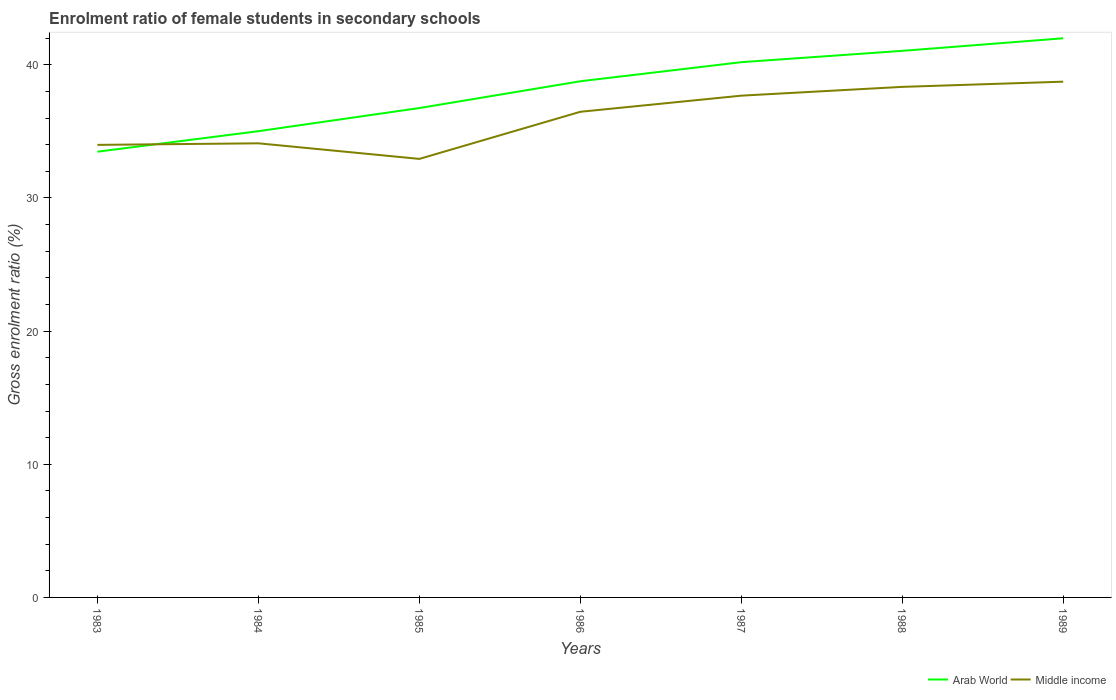Does the line corresponding to Arab World intersect with the line corresponding to Middle income?
Your answer should be compact. Yes. Across all years, what is the maximum enrolment ratio of female students in secondary schools in Middle income?
Provide a short and direct response. 32.93. What is the total enrolment ratio of female students in secondary schools in Arab World in the graph?
Your response must be concise. -1.79. What is the difference between the highest and the second highest enrolment ratio of female students in secondary schools in Arab World?
Provide a short and direct response. 8.52. Is the enrolment ratio of female students in secondary schools in Middle income strictly greater than the enrolment ratio of female students in secondary schools in Arab World over the years?
Your answer should be very brief. No. How many lines are there?
Ensure brevity in your answer.  2. What is the difference between two consecutive major ticks on the Y-axis?
Provide a short and direct response. 10. Does the graph contain any zero values?
Your response must be concise. No. How are the legend labels stacked?
Make the answer very short. Horizontal. What is the title of the graph?
Offer a very short reply. Enrolment ratio of female students in secondary schools. What is the Gross enrolment ratio (%) in Arab World in 1983?
Keep it short and to the point. 33.47. What is the Gross enrolment ratio (%) of Middle income in 1983?
Your answer should be very brief. 33.99. What is the Gross enrolment ratio (%) in Arab World in 1984?
Give a very brief answer. 35.01. What is the Gross enrolment ratio (%) of Middle income in 1984?
Your response must be concise. 34.1. What is the Gross enrolment ratio (%) of Arab World in 1985?
Make the answer very short. 36.75. What is the Gross enrolment ratio (%) in Middle income in 1985?
Your answer should be compact. 32.93. What is the Gross enrolment ratio (%) in Arab World in 1986?
Provide a short and direct response. 38.76. What is the Gross enrolment ratio (%) in Middle income in 1986?
Make the answer very short. 36.47. What is the Gross enrolment ratio (%) of Arab World in 1987?
Give a very brief answer. 40.2. What is the Gross enrolment ratio (%) in Middle income in 1987?
Provide a succinct answer. 37.68. What is the Gross enrolment ratio (%) in Arab World in 1988?
Offer a very short reply. 41.05. What is the Gross enrolment ratio (%) in Middle income in 1988?
Ensure brevity in your answer.  38.34. What is the Gross enrolment ratio (%) in Arab World in 1989?
Your answer should be compact. 41.99. What is the Gross enrolment ratio (%) of Middle income in 1989?
Give a very brief answer. 38.73. Across all years, what is the maximum Gross enrolment ratio (%) in Arab World?
Provide a succinct answer. 41.99. Across all years, what is the maximum Gross enrolment ratio (%) in Middle income?
Offer a terse response. 38.73. Across all years, what is the minimum Gross enrolment ratio (%) in Arab World?
Offer a terse response. 33.47. Across all years, what is the minimum Gross enrolment ratio (%) of Middle income?
Make the answer very short. 32.93. What is the total Gross enrolment ratio (%) of Arab World in the graph?
Offer a very short reply. 267.24. What is the total Gross enrolment ratio (%) in Middle income in the graph?
Keep it short and to the point. 252.25. What is the difference between the Gross enrolment ratio (%) in Arab World in 1983 and that in 1984?
Provide a short and direct response. -1.54. What is the difference between the Gross enrolment ratio (%) in Middle income in 1983 and that in 1984?
Ensure brevity in your answer.  -0.12. What is the difference between the Gross enrolment ratio (%) of Arab World in 1983 and that in 1985?
Ensure brevity in your answer.  -3.28. What is the difference between the Gross enrolment ratio (%) in Middle income in 1983 and that in 1985?
Provide a succinct answer. 1.05. What is the difference between the Gross enrolment ratio (%) in Arab World in 1983 and that in 1986?
Offer a terse response. -5.29. What is the difference between the Gross enrolment ratio (%) in Middle income in 1983 and that in 1986?
Offer a terse response. -2.48. What is the difference between the Gross enrolment ratio (%) in Arab World in 1983 and that in 1987?
Offer a very short reply. -6.72. What is the difference between the Gross enrolment ratio (%) in Middle income in 1983 and that in 1987?
Give a very brief answer. -3.7. What is the difference between the Gross enrolment ratio (%) of Arab World in 1983 and that in 1988?
Ensure brevity in your answer.  -7.57. What is the difference between the Gross enrolment ratio (%) of Middle income in 1983 and that in 1988?
Provide a short and direct response. -4.36. What is the difference between the Gross enrolment ratio (%) of Arab World in 1983 and that in 1989?
Give a very brief answer. -8.52. What is the difference between the Gross enrolment ratio (%) in Middle income in 1983 and that in 1989?
Ensure brevity in your answer.  -4.75. What is the difference between the Gross enrolment ratio (%) of Arab World in 1984 and that in 1985?
Offer a very short reply. -1.74. What is the difference between the Gross enrolment ratio (%) of Middle income in 1984 and that in 1985?
Your response must be concise. 1.17. What is the difference between the Gross enrolment ratio (%) of Arab World in 1984 and that in 1986?
Your answer should be compact. -3.75. What is the difference between the Gross enrolment ratio (%) of Middle income in 1984 and that in 1986?
Your response must be concise. -2.37. What is the difference between the Gross enrolment ratio (%) in Arab World in 1984 and that in 1987?
Offer a terse response. -5.18. What is the difference between the Gross enrolment ratio (%) in Middle income in 1984 and that in 1987?
Offer a terse response. -3.58. What is the difference between the Gross enrolment ratio (%) of Arab World in 1984 and that in 1988?
Ensure brevity in your answer.  -6.03. What is the difference between the Gross enrolment ratio (%) in Middle income in 1984 and that in 1988?
Give a very brief answer. -4.24. What is the difference between the Gross enrolment ratio (%) of Arab World in 1984 and that in 1989?
Offer a very short reply. -6.98. What is the difference between the Gross enrolment ratio (%) in Middle income in 1984 and that in 1989?
Your answer should be compact. -4.63. What is the difference between the Gross enrolment ratio (%) of Arab World in 1985 and that in 1986?
Ensure brevity in your answer.  -2.01. What is the difference between the Gross enrolment ratio (%) of Middle income in 1985 and that in 1986?
Provide a short and direct response. -3.54. What is the difference between the Gross enrolment ratio (%) of Arab World in 1985 and that in 1987?
Offer a terse response. -3.44. What is the difference between the Gross enrolment ratio (%) of Middle income in 1985 and that in 1987?
Your answer should be compact. -4.75. What is the difference between the Gross enrolment ratio (%) of Arab World in 1985 and that in 1988?
Your answer should be compact. -4.3. What is the difference between the Gross enrolment ratio (%) in Middle income in 1985 and that in 1988?
Provide a short and direct response. -5.41. What is the difference between the Gross enrolment ratio (%) in Arab World in 1985 and that in 1989?
Offer a very short reply. -5.24. What is the difference between the Gross enrolment ratio (%) of Middle income in 1985 and that in 1989?
Make the answer very short. -5.8. What is the difference between the Gross enrolment ratio (%) of Arab World in 1986 and that in 1987?
Make the answer very short. -1.43. What is the difference between the Gross enrolment ratio (%) in Middle income in 1986 and that in 1987?
Ensure brevity in your answer.  -1.21. What is the difference between the Gross enrolment ratio (%) of Arab World in 1986 and that in 1988?
Give a very brief answer. -2.28. What is the difference between the Gross enrolment ratio (%) of Middle income in 1986 and that in 1988?
Ensure brevity in your answer.  -1.87. What is the difference between the Gross enrolment ratio (%) of Arab World in 1986 and that in 1989?
Provide a short and direct response. -3.23. What is the difference between the Gross enrolment ratio (%) in Middle income in 1986 and that in 1989?
Give a very brief answer. -2.26. What is the difference between the Gross enrolment ratio (%) of Arab World in 1987 and that in 1988?
Provide a short and direct response. -0.85. What is the difference between the Gross enrolment ratio (%) in Middle income in 1987 and that in 1988?
Provide a succinct answer. -0.66. What is the difference between the Gross enrolment ratio (%) of Arab World in 1987 and that in 1989?
Provide a short and direct response. -1.79. What is the difference between the Gross enrolment ratio (%) of Middle income in 1987 and that in 1989?
Ensure brevity in your answer.  -1.05. What is the difference between the Gross enrolment ratio (%) in Arab World in 1988 and that in 1989?
Offer a terse response. -0.94. What is the difference between the Gross enrolment ratio (%) in Middle income in 1988 and that in 1989?
Provide a short and direct response. -0.39. What is the difference between the Gross enrolment ratio (%) in Arab World in 1983 and the Gross enrolment ratio (%) in Middle income in 1984?
Give a very brief answer. -0.63. What is the difference between the Gross enrolment ratio (%) in Arab World in 1983 and the Gross enrolment ratio (%) in Middle income in 1985?
Give a very brief answer. 0.54. What is the difference between the Gross enrolment ratio (%) of Arab World in 1983 and the Gross enrolment ratio (%) of Middle income in 1986?
Offer a terse response. -3. What is the difference between the Gross enrolment ratio (%) of Arab World in 1983 and the Gross enrolment ratio (%) of Middle income in 1987?
Your answer should be very brief. -4.21. What is the difference between the Gross enrolment ratio (%) of Arab World in 1983 and the Gross enrolment ratio (%) of Middle income in 1988?
Your answer should be very brief. -4.87. What is the difference between the Gross enrolment ratio (%) in Arab World in 1983 and the Gross enrolment ratio (%) in Middle income in 1989?
Offer a terse response. -5.26. What is the difference between the Gross enrolment ratio (%) of Arab World in 1984 and the Gross enrolment ratio (%) of Middle income in 1985?
Your answer should be compact. 2.08. What is the difference between the Gross enrolment ratio (%) in Arab World in 1984 and the Gross enrolment ratio (%) in Middle income in 1986?
Offer a very short reply. -1.46. What is the difference between the Gross enrolment ratio (%) in Arab World in 1984 and the Gross enrolment ratio (%) in Middle income in 1987?
Give a very brief answer. -2.67. What is the difference between the Gross enrolment ratio (%) of Arab World in 1984 and the Gross enrolment ratio (%) of Middle income in 1988?
Provide a succinct answer. -3.33. What is the difference between the Gross enrolment ratio (%) in Arab World in 1984 and the Gross enrolment ratio (%) in Middle income in 1989?
Offer a very short reply. -3.72. What is the difference between the Gross enrolment ratio (%) of Arab World in 1985 and the Gross enrolment ratio (%) of Middle income in 1986?
Give a very brief answer. 0.28. What is the difference between the Gross enrolment ratio (%) in Arab World in 1985 and the Gross enrolment ratio (%) in Middle income in 1987?
Ensure brevity in your answer.  -0.93. What is the difference between the Gross enrolment ratio (%) of Arab World in 1985 and the Gross enrolment ratio (%) of Middle income in 1988?
Make the answer very short. -1.59. What is the difference between the Gross enrolment ratio (%) of Arab World in 1985 and the Gross enrolment ratio (%) of Middle income in 1989?
Provide a short and direct response. -1.98. What is the difference between the Gross enrolment ratio (%) of Arab World in 1986 and the Gross enrolment ratio (%) of Middle income in 1987?
Your response must be concise. 1.08. What is the difference between the Gross enrolment ratio (%) in Arab World in 1986 and the Gross enrolment ratio (%) in Middle income in 1988?
Offer a terse response. 0.42. What is the difference between the Gross enrolment ratio (%) of Arab World in 1986 and the Gross enrolment ratio (%) of Middle income in 1989?
Make the answer very short. 0.03. What is the difference between the Gross enrolment ratio (%) of Arab World in 1987 and the Gross enrolment ratio (%) of Middle income in 1988?
Give a very brief answer. 1.85. What is the difference between the Gross enrolment ratio (%) of Arab World in 1987 and the Gross enrolment ratio (%) of Middle income in 1989?
Your answer should be compact. 1.46. What is the difference between the Gross enrolment ratio (%) in Arab World in 1988 and the Gross enrolment ratio (%) in Middle income in 1989?
Offer a terse response. 2.31. What is the average Gross enrolment ratio (%) of Arab World per year?
Your answer should be compact. 38.18. What is the average Gross enrolment ratio (%) in Middle income per year?
Your response must be concise. 36.04. In the year 1983, what is the difference between the Gross enrolment ratio (%) of Arab World and Gross enrolment ratio (%) of Middle income?
Provide a short and direct response. -0.51. In the year 1984, what is the difference between the Gross enrolment ratio (%) of Arab World and Gross enrolment ratio (%) of Middle income?
Offer a very short reply. 0.91. In the year 1985, what is the difference between the Gross enrolment ratio (%) in Arab World and Gross enrolment ratio (%) in Middle income?
Provide a succinct answer. 3.82. In the year 1986, what is the difference between the Gross enrolment ratio (%) of Arab World and Gross enrolment ratio (%) of Middle income?
Offer a terse response. 2.29. In the year 1987, what is the difference between the Gross enrolment ratio (%) in Arab World and Gross enrolment ratio (%) in Middle income?
Offer a terse response. 2.51. In the year 1988, what is the difference between the Gross enrolment ratio (%) in Arab World and Gross enrolment ratio (%) in Middle income?
Provide a succinct answer. 2.71. In the year 1989, what is the difference between the Gross enrolment ratio (%) of Arab World and Gross enrolment ratio (%) of Middle income?
Your answer should be compact. 3.26. What is the ratio of the Gross enrolment ratio (%) of Arab World in 1983 to that in 1984?
Ensure brevity in your answer.  0.96. What is the ratio of the Gross enrolment ratio (%) of Arab World in 1983 to that in 1985?
Offer a terse response. 0.91. What is the ratio of the Gross enrolment ratio (%) of Middle income in 1983 to that in 1985?
Your response must be concise. 1.03. What is the ratio of the Gross enrolment ratio (%) in Arab World in 1983 to that in 1986?
Make the answer very short. 0.86. What is the ratio of the Gross enrolment ratio (%) of Middle income in 1983 to that in 1986?
Offer a very short reply. 0.93. What is the ratio of the Gross enrolment ratio (%) of Arab World in 1983 to that in 1987?
Your response must be concise. 0.83. What is the ratio of the Gross enrolment ratio (%) of Middle income in 1983 to that in 1987?
Ensure brevity in your answer.  0.9. What is the ratio of the Gross enrolment ratio (%) of Arab World in 1983 to that in 1988?
Make the answer very short. 0.82. What is the ratio of the Gross enrolment ratio (%) of Middle income in 1983 to that in 1988?
Provide a succinct answer. 0.89. What is the ratio of the Gross enrolment ratio (%) in Arab World in 1983 to that in 1989?
Keep it short and to the point. 0.8. What is the ratio of the Gross enrolment ratio (%) of Middle income in 1983 to that in 1989?
Offer a terse response. 0.88. What is the ratio of the Gross enrolment ratio (%) in Arab World in 1984 to that in 1985?
Offer a very short reply. 0.95. What is the ratio of the Gross enrolment ratio (%) of Middle income in 1984 to that in 1985?
Ensure brevity in your answer.  1.04. What is the ratio of the Gross enrolment ratio (%) in Arab World in 1984 to that in 1986?
Provide a short and direct response. 0.9. What is the ratio of the Gross enrolment ratio (%) of Middle income in 1984 to that in 1986?
Give a very brief answer. 0.94. What is the ratio of the Gross enrolment ratio (%) in Arab World in 1984 to that in 1987?
Ensure brevity in your answer.  0.87. What is the ratio of the Gross enrolment ratio (%) in Middle income in 1984 to that in 1987?
Your response must be concise. 0.91. What is the ratio of the Gross enrolment ratio (%) in Arab World in 1984 to that in 1988?
Your answer should be very brief. 0.85. What is the ratio of the Gross enrolment ratio (%) in Middle income in 1984 to that in 1988?
Offer a terse response. 0.89. What is the ratio of the Gross enrolment ratio (%) of Arab World in 1984 to that in 1989?
Keep it short and to the point. 0.83. What is the ratio of the Gross enrolment ratio (%) of Middle income in 1984 to that in 1989?
Keep it short and to the point. 0.88. What is the ratio of the Gross enrolment ratio (%) in Arab World in 1985 to that in 1986?
Your response must be concise. 0.95. What is the ratio of the Gross enrolment ratio (%) in Middle income in 1985 to that in 1986?
Give a very brief answer. 0.9. What is the ratio of the Gross enrolment ratio (%) in Arab World in 1985 to that in 1987?
Give a very brief answer. 0.91. What is the ratio of the Gross enrolment ratio (%) of Middle income in 1985 to that in 1987?
Make the answer very short. 0.87. What is the ratio of the Gross enrolment ratio (%) in Arab World in 1985 to that in 1988?
Make the answer very short. 0.9. What is the ratio of the Gross enrolment ratio (%) in Middle income in 1985 to that in 1988?
Your answer should be very brief. 0.86. What is the ratio of the Gross enrolment ratio (%) in Arab World in 1985 to that in 1989?
Your response must be concise. 0.88. What is the ratio of the Gross enrolment ratio (%) of Middle income in 1985 to that in 1989?
Offer a very short reply. 0.85. What is the ratio of the Gross enrolment ratio (%) of Arab World in 1986 to that in 1987?
Your response must be concise. 0.96. What is the ratio of the Gross enrolment ratio (%) of Middle income in 1986 to that in 1987?
Offer a very short reply. 0.97. What is the ratio of the Gross enrolment ratio (%) in Arab World in 1986 to that in 1988?
Ensure brevity in your answer.  0.94. What is the ratio of the Gross enrolment ratio (%) in Middle income in 1986 to that in 1988?
Keep it short and to the point. 0.95. What is the ratio of the Gross enrolment ratio (%) in Middle income in 1986 to that in 1989?
Offer a terse response. 0.94. What is the ratio of the Gross enrolment ratio (%) of Arab World in 1987 to that in 1988?
Keep it short and to the point. 0.98. What is the ratio of the Gross enrolment ratio (%) of Middle income in 1987 to that in 1988?
Your answer should be compact. 0.98. What is the ratio of the Gross enrolment ratio (%) of Arab World in 1987 to that in 1989?
Your response must be concise. 0.96. What is the ratio of the Gross enrolment ratio (%) of Middle income in 1987 to that in 1989?
Ensure brevity in your answer.  0.97. What is the ratio of the Gross enrolment ratio (%) of Arab World in 1988 to that in 1989?
Offer a terse response. 0.98. What is the ratio of the Gross enrolment ratio (%) of Middle income in 1988 to that in 1989?
Your response must be concise. 0.99. What is the difference between the highest and the second highest Gross enrolment ratio (%) of Arab World?
Provide a succinct answer. 0.94. What is the difference between the highest and the second highest Gross enrolment ratio (%) of Middle income?
Ensure brevity in your answer.  0.39. What is the difference between the highest and the lowest Gross enrolment ratio (%) in Arab World?
Provide a succinct answer. 8.52. What is the difference between the highest and the lowest Gross enrolment ratio (%) in Middle income?
Your answer should be compact. 5.8. 